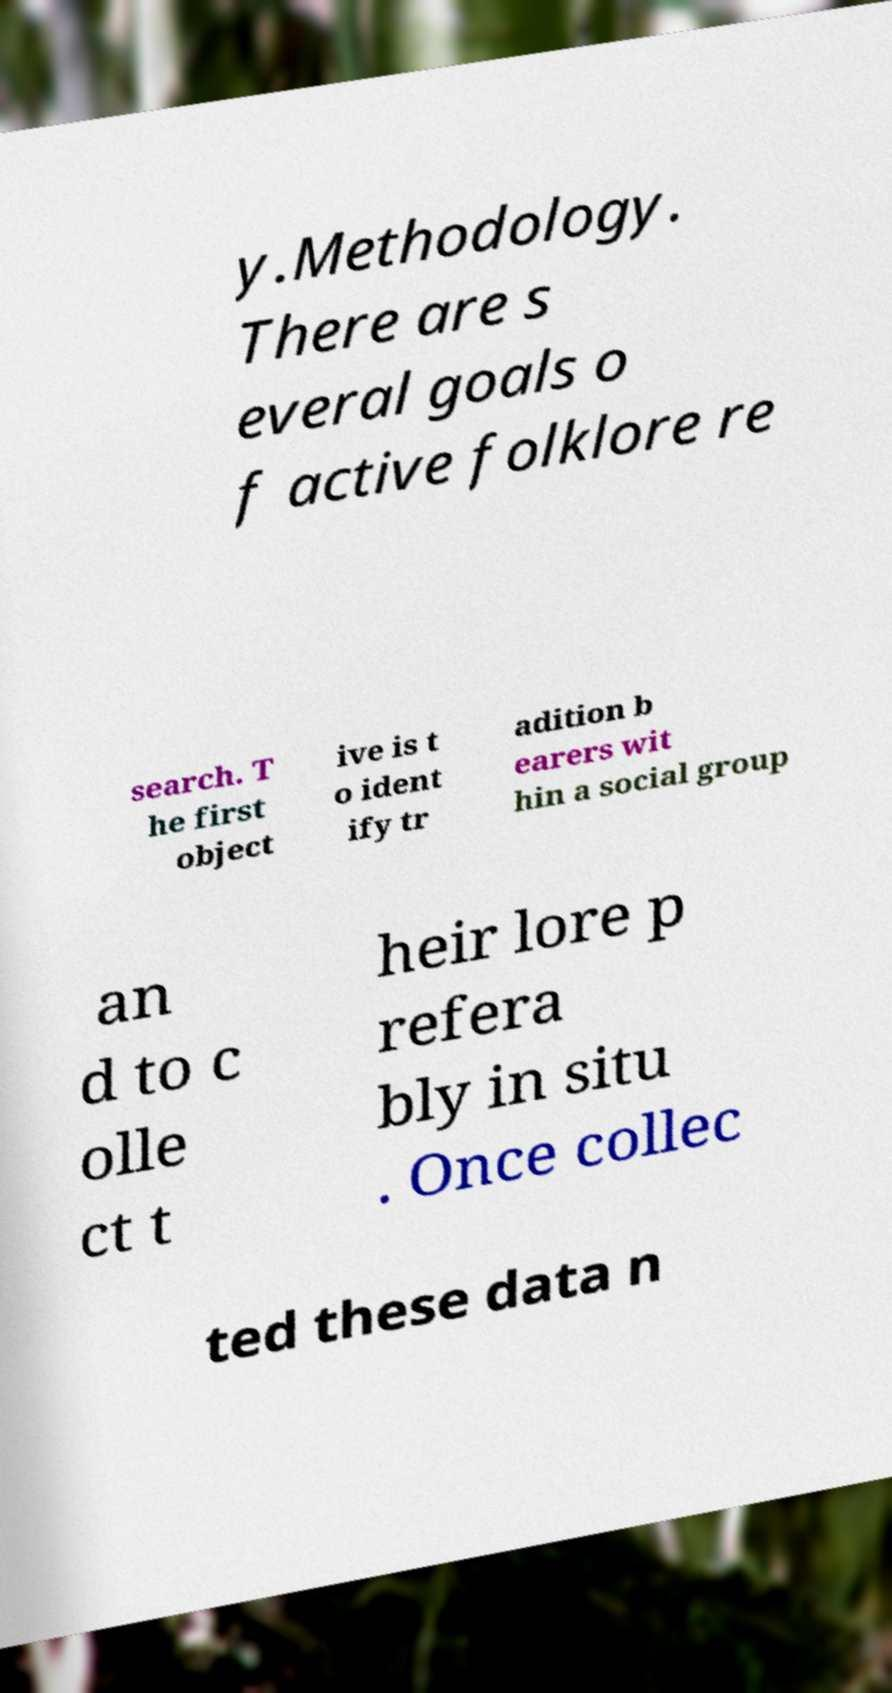I need the written content from this picture converted into text. Can you do that? y.Methodology. There are s everal goals o f active folklore re search. T he first object ive is t o ident ify tr adition b earers wit hin a social group an d to c olle ct t heir lore p refera bly in situ . Once collec ted these data n 